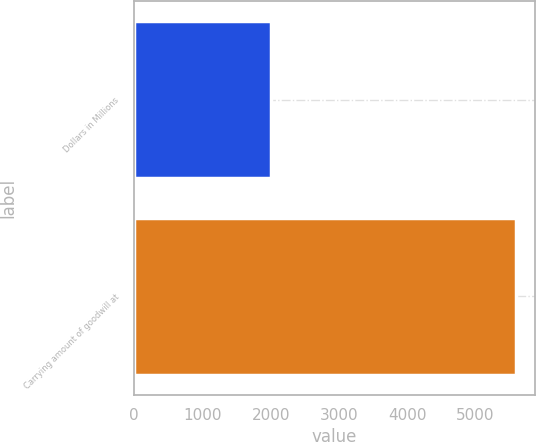Convert chart to OTSL. <chart><loc_0><loc_0><loc_500><loc_500><bar_chart><fcel>Dollars in Millions<fcel>Carrying amount of goodwill at<nl><fcel>2011<fcel>5590.5<nl></chart> 